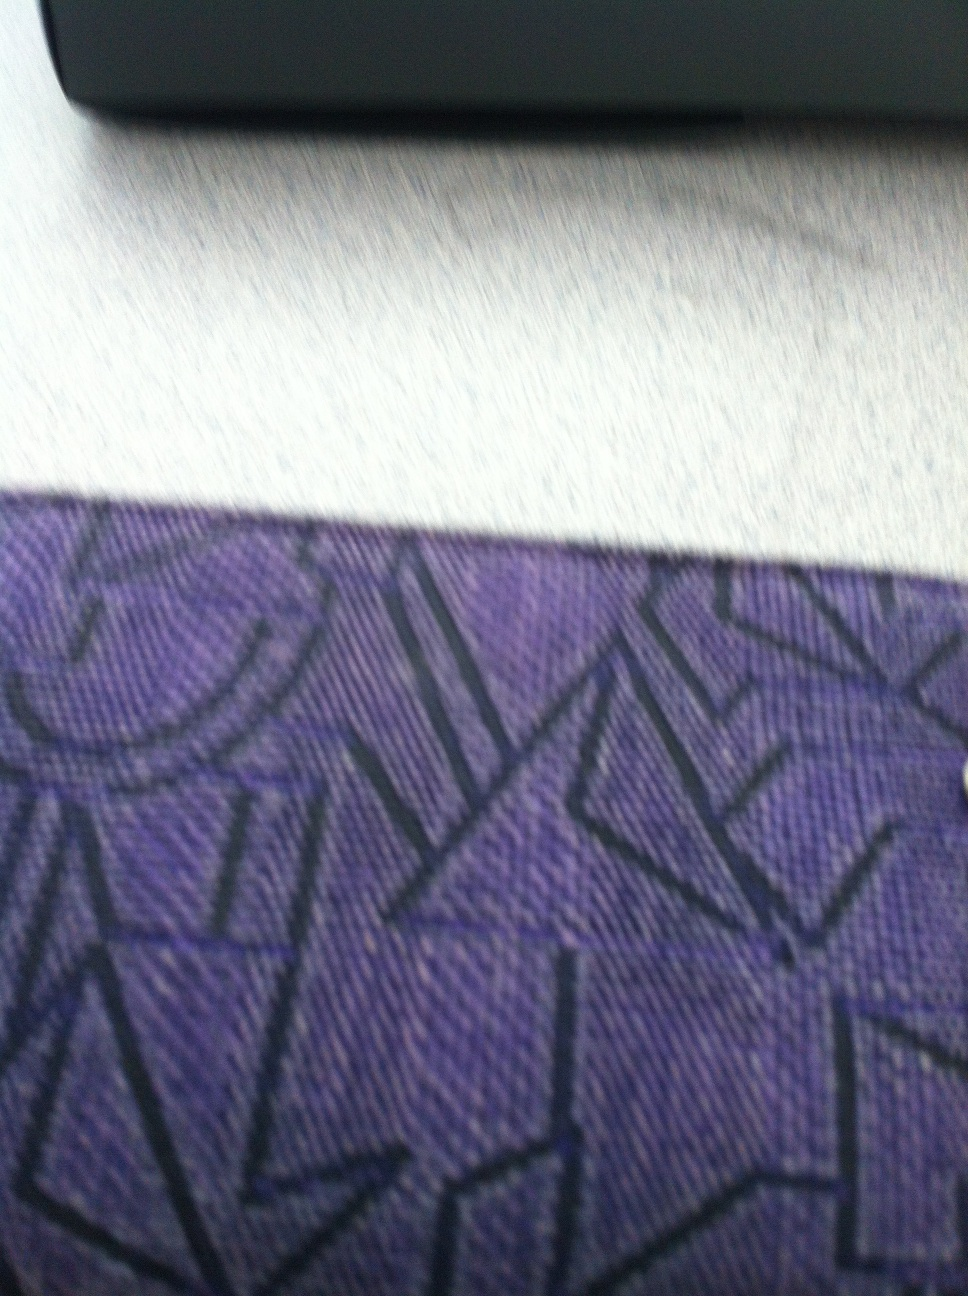What color is my wallet? The color of your wallet appears to be a deep purple with geometric patterns. It has a textured fabric that gives it a stylish and unique look. 